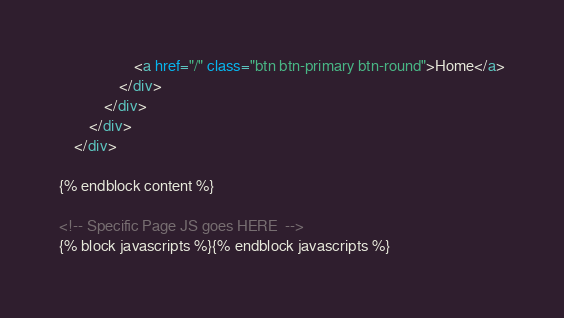Convert code to text. <code><loc_0><loc_0><loc_500><loc_500><_HTML_>                    <a href="/" class="btn btn-primary btn-round">Home</a>
                </div>
            </div>
        </div>
    </div>
    
{% endblock content %}

<!-- Specific Page JS goes HERE  -->
{% block javascripts %}{% endblock javascripts %}
</code> 